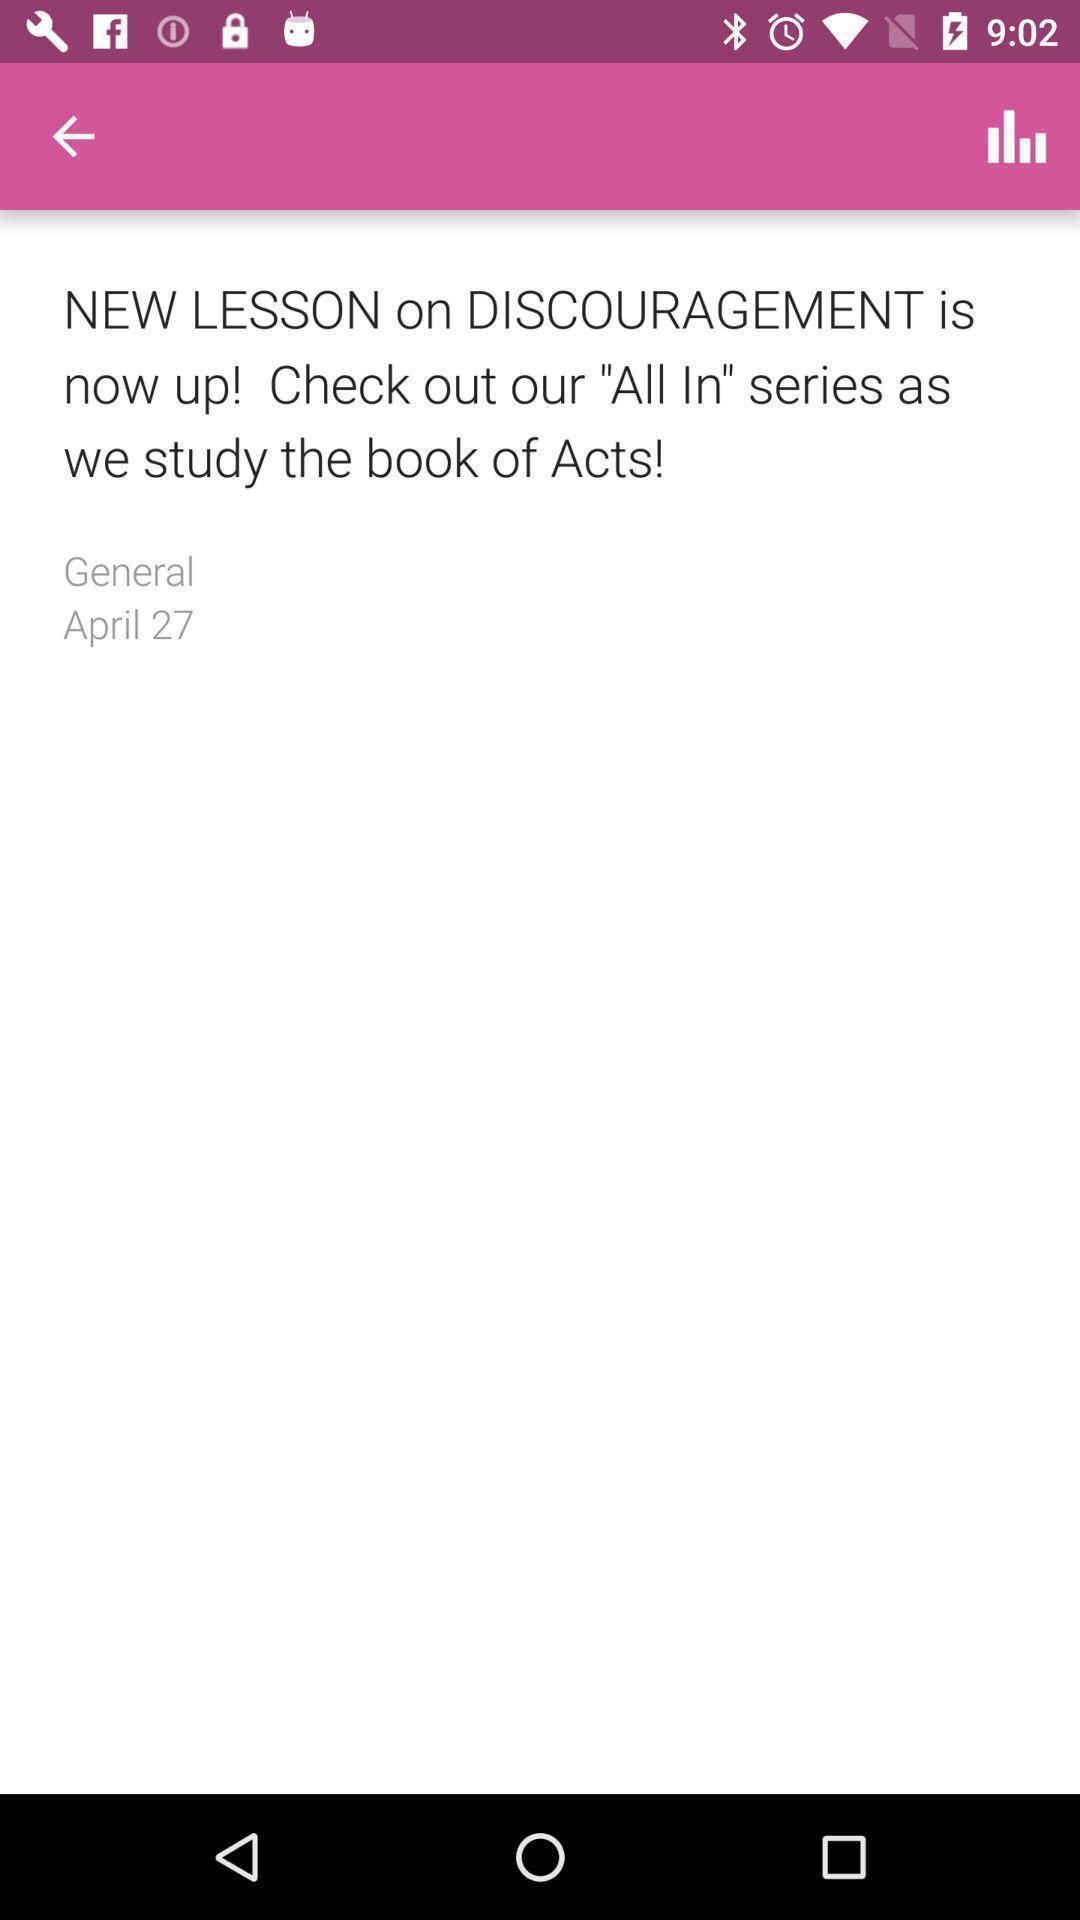Summarize the information in this screenshot. Page displaying some information. 